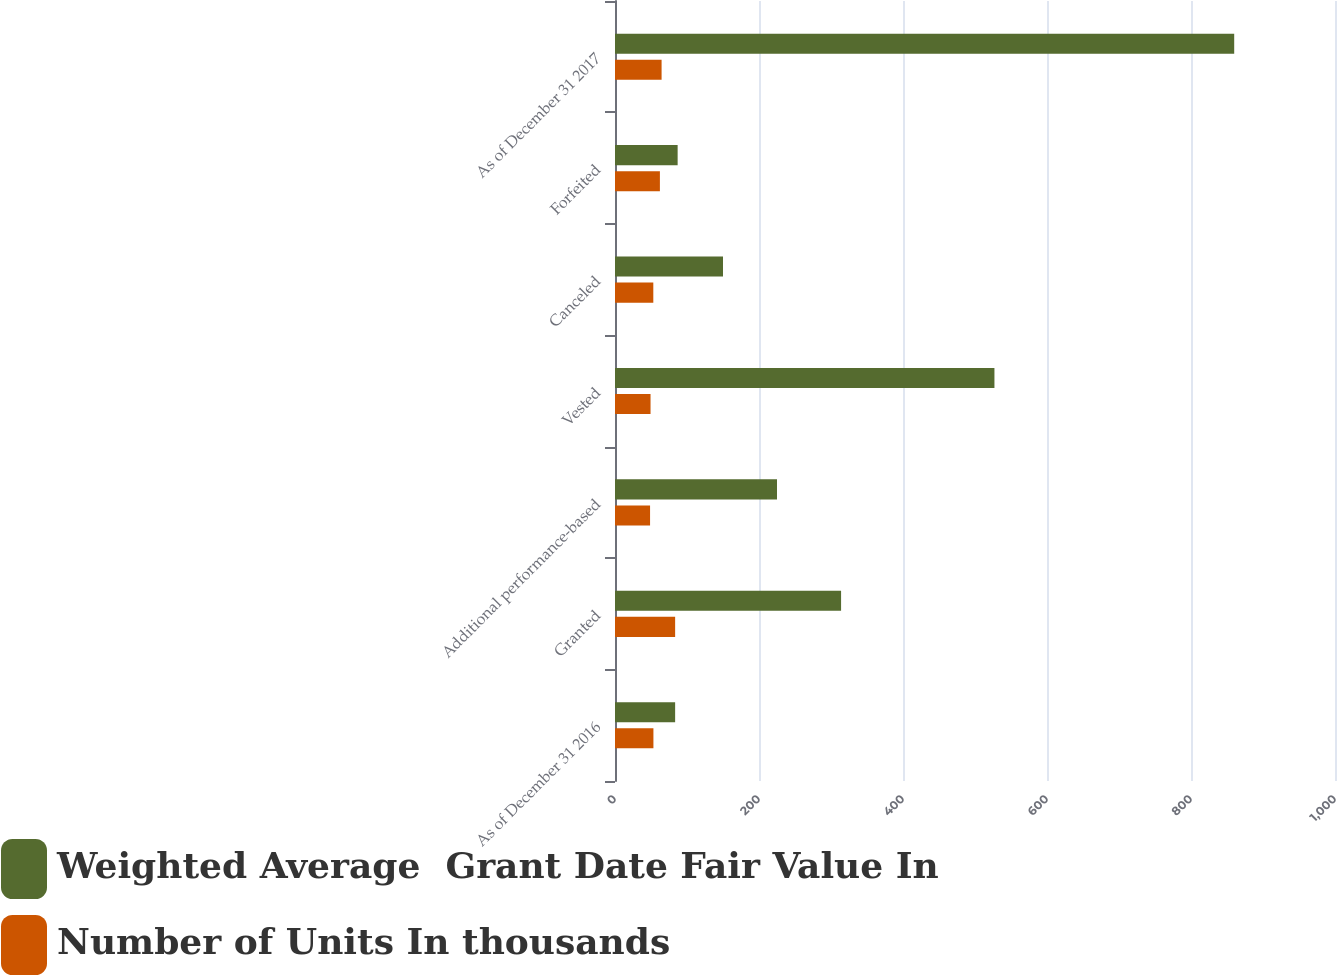Convert chart. <chart><loc_0><loc_0><loc_500><loc_500><stacked_bar_chart><ecel><fcel>As of December 31 2016<fcel>Granted<fcel>Additional performance-based<fcel>Vested<fcel>Canceled<fcel>Forfeited<fcel>As of December 31 2017<nl><fcel>Weighted Average  Grant Date Fair Value In<fcel>83.52<fcel>314<fcel>225<fcel>527<fcel>150<fcel>87<fcel>860<nl><fcel>Number of Units In thousands<fcel>53.36<fcel>83.52<fcel>48.7<fcel>49.36<fcel>53.21<fcel>62.36<fcel>64.71<nl></chart> 